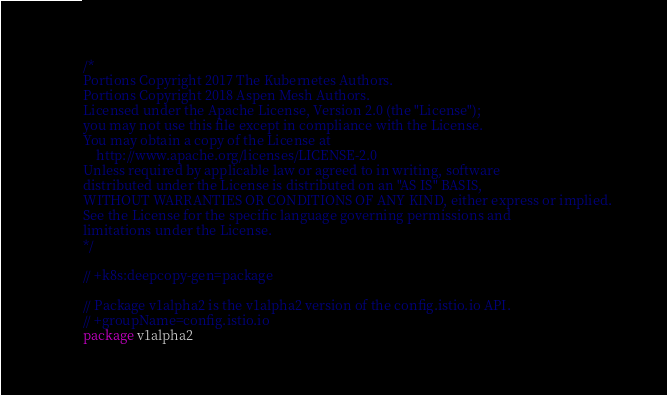<code> <loc_0><loc_0><loc_500><loc_500><_Go_>/*
Portions Copyright 2017 The Kubernetes Authors.
Portions Copyright 2018 Aspen Mesh Authors.
Licensed under the Apache License, Version 2.0 (the "License");
you may not use this file except in compliance with the License.
You may obtain a copy of the License at
    http://www.apache.org/licenses/LICENSE-2.0
Unless required by applicable law or agreed to in writing, software
distributed under the License is distributed on an "AS IS" BASIS,
WITHOUT WARRANTIES OR CONDITIONS OF ANY KIND, either express or implied.
See the License for the specific language governing permissions and
limitations under the License.
*/

// +k8s:deepcopy-gen=package

// Package v1alpha2 is the v1alpha2 version of the config.istio.io API.
// +groupName=config.istio.io
package v1alpha2
</code> 